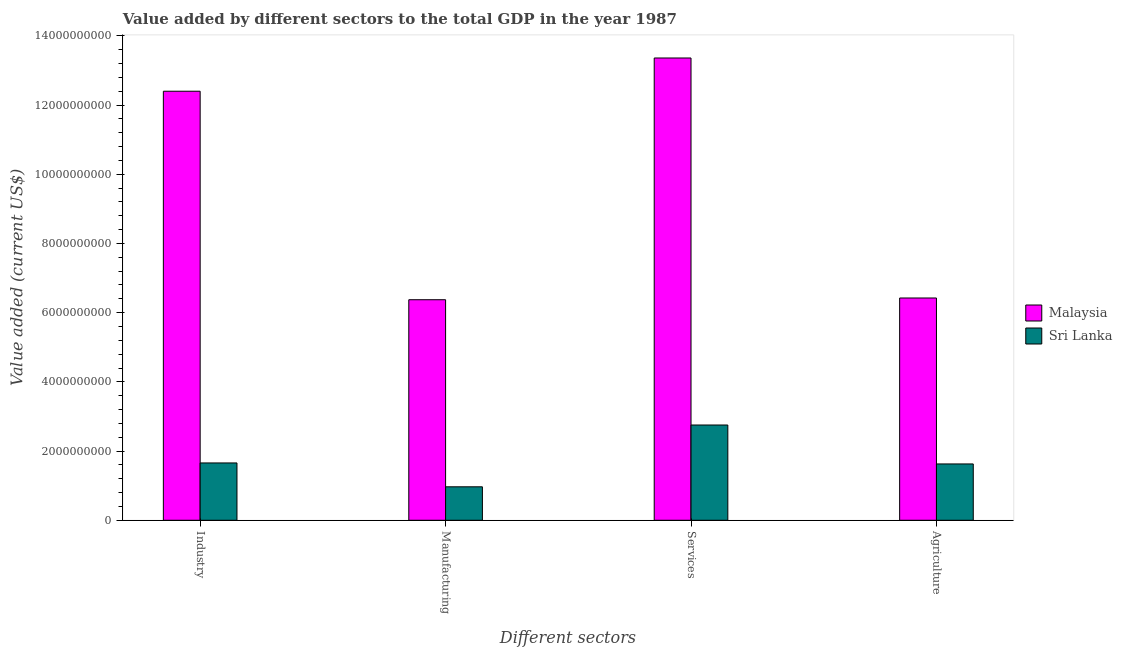Are the number of bars on each tick of the X-axis equal?
Keep it short and to the point. Yes. How many bars are there on the 3rd tick from the left?
Ensure brevity in your answer.  2. What is the label of the 4th group of bars from the left?
Give a very brief answer. Agriculture. What is the value added by services sector in Malaysia?
Make the answer very short. 1.34e+1. Across all countries, what is the maximum value added by manufacturing sector?
Make the answer very short. 6.37e+09. Across all countries, what is the minimum value added by manufacturing sector?
Offer a terse response. 9.67e+08. In which country was the value added by agricultural sector maximum?
Your answer should be very brief. Malaysia. In which country was the value added by manufacturing sector minimum?
Offer a terse response. Sri Lanka. What is the total value added by agricultural sector in the graph?
Your response must be concise. 8.05e+09. What is the difference between the value added by agricultural sector in Malaysia and that in Sri Lanka?
Ensure brevity in your answer.  4.80e+09. What is the difference between the value added by services sector in Malaysia and the value added by manufacturing sector in Sri Lanka?
Offer a very short reply. 1.24e+1. What is the average value added by agricultural sector per country?
Give a very brief answer. 4.03e+09. What is the difference between the value added by manufacturing sector and value added by industrial sector in Sri Lanka?
Offer a terse response. -6.89e+08. What is the ratio of the value added by manufacturing sector in Malaysia to that in Sri Lanka?
Your answer should be very brief. 6.59. Is the value added by services sector in Malaysia less than that in Sri Lanka?
Give a very brief answer. No. Is the difference between the value added by manufacturing sector in Sri Lanka and Malaysia greater than the difference between the value added by services sector in Sri Lanka and Malaysia?
Offer a terse response. Yes. What is the difference between the highest and the second highest value added by services sector?
Ensure brevity in your answer.  1.06e+1. What is the difference between the highest and the lowest value added by manufacturing sector?
Keep it short and to the point. 5.41e+09. In how many countries, is the value added by manufacturing sector greater than the average value added by manufacturing sector taken over all countries?
Offer a terse response. 1. Is it the case that in every country, the sum of the value added by agricultural sector and value added by manufacturing sector is greater than the sum of value added by services sector and value added by industrial sector?
Provide a succinct answer. No. What does the 2nd bar from the left in Manufacturing represents?
Provide a succinct answer. Sri Lanka. What does the 1st bar from the right in Services represents?
Offer a terse response. Sri Lanka. Is it the case that in every country, the sum of the value added by industrial sector and value added by manufacturing sector is greater than the value added by services sector?
Provide a succinct answer. No. How many bars are there?
Your response must be concise. 8. Does the graph contain any zero values?
Give a very brief answer. No. Does the graph contain grids?
Keep it short and to the point. No. Where does the legend appear in the graph?
Your response must be concise. Center right. What is the title of the graph?
Provide a short and direct response. Value added by different sectors to the total GDP in the year 1987. What is the label or title of the X-axis?
Offer a very short reply. Different sectors. What is the label or title of the Y-axis?
Your answer should be very brief. Value added (current US$). What is the Value added (current US$) of Malaysia in Industry?
Your response must be concise. 1.24e+1. What is the Value added (current US$) in Sri Lanka in Industry?
Keep it short and to the point. 1.66e+09. What is the Value added (current US$) of Malaysia in Manufacturing?
Your answer should be compact. 6.37e+09. What is the Value added (current US$) in Sri Lanka in Manufacturing?
Offer a terse response. 9.67e+08. What is the Value added (current US$) of Malaysia in Services?
Your answer should be very brief. 1.34e+1. What is the Value added (current US$) of Sri Lanka in Services?
Ensure brevity in your answer.  2.75e+09. What is the Value added (current US$) in Malaysia in Agriculture?
Ensure brevity in your answer.  6.42e+09. What is the Value added (current US$) in Sri Lanka in Agriculture?
Your response must be concise. 1.63e+09. Across all Different sectors, what is the maximum Value added (current US$) of Malaysia?
Your answer should be very brief. 1.34e+1. Across all Different sectors, what is the maximum Value added (current US$) of Sri Lanka?
Your answer should be compact. 2.75e+09. Across all Different sectors, what is the minimum Value added (current US$) of Malaysia?
Your response must be concise. 6.37e+09. Across all Different sectors, what is the minimum Value added (current US$) in Sri Lanka?
Your answer should be compact. 9.67e+08. What is the total Value added (current US$) of Malaysia in the graph?
Offer a very short reply. 3.86e+1. What is the total Value added (current US$) of Sri Lanka in the graph?
Keep it short and to the point. 7.00e+09. What is the difference between the Value added (current US$) of Malaysia in Industry and that in Manufacturing?
Keep it short and to the point. 6.03e+09. What is the difference between the Value added (current US$) of Sri Lanka in Industry and that in Manufacturing?
Your response must be concise. 6.89e+08. What is the difference between the Value added (current US$) in Malaysia in Industry and that in Services?
Offer a very short reply. -9.60e+08. What is the difference between the Value added (current US$) of Sri Lanka in Industry and that in Services?
Provide a short and direct response. -1.10e+09. What is the difference between the Value added (current US$) in Malaysia in Industry and that in Agriculture?
Your answer should be compact. 5.98e+09. What is the difference between the Value added (current US$) in Sri Lanka in Industry and that in Agriculture?
Provide a succinct answer. 2.85e+07. What is the difference between the Value added (current US$) in Malaysia in Manufacturing and that in Services?
Offer a very short reply. -6.99e+09. What is the difference between the Value added (current US$) of Sri Lanka in Manufacturing and that in Services?
Offer a very short reply. -1.79e+09. What is the difference between the Value added (current US$) in Malaysia in Manufacturing and that in Agriculture?
Give a very brief answer. -5.04e+07. What is the difference between the Value added (current US$) of Sri Lanka in Manufacturing and that in Agriculture?
Your response must be concise. -6.61e+08. What is the difference between the Value added (current US$) in Malaysia in Services and that in Agriculture?
Provide a short and direct response. 6.94e+09. What is the difference between the Value added (current US$) of Sri Lanka in Services and that in Agriculture?
Offer a very short reply. 1.13e+09. What is the difference between the Value added (current US$) in Malaysia in Industry and the Value added (current US$) in Sri Lanka in Manufacturing?
Provide a short and direct response. 1.14e+1. What is the difference between the Value added (current US$) in Malaysia in Industry and the Value added (current US$) in Sri Lanka in Services?
Ensure brevity in your answer.  9.65e+09. What is the difference between the Value added (current US$) of Malaysia in Industry and the Value added (current US$) of Sri Lanka in Agriculture?
Your response must be concise. 1.08e+1. What is the difference between the Value added (current US$) in Malaysia in Manufacturing and the Value added (current US$) in Sri Lanka in Services?
Provide a succinct answer. 3.62e+09. What is the difference between the Value added (current US$) in Malaysia in Manufacturing and the Value added (current US$) in Sri Lanka in Agriculture?
Your response must be concise. 4.75e+09. What is the difference between the Value added (current US$) in Malaysia in Services and the Value added (current US$) in Sri Lanka in Agriculture?
Give a very brief answer. 1.17e+1. What is the average Value added (current US$) of Malaysia per Different sectors?
Your response must be concise. 9.64e+09. What is the average Value added (current US$) in Sri Lanka per Different sectors?
Your answer should be very brief. 1.75e+09. What is the difference between the Value added (current US$) in Malaysia and Value added (current US$) in Sri Lanka in Industry?
Provide a short and direct response. 1.07e+1. What is the difference between the Value added (current US$) of Malaysia and Value added (current US$) of Sri Lanka in Manufacturing?
Give a very brief answer. 5.41e+09. What is the difference between the Value added (current US$) of Malaysia and Value added (current US$) of Sri Lanka in Services?
Your answer should be very brief. 1.06e+1. What is the difference between the Value added (current US$) of Malaysia and Value added (current US$) of Sri Lanka in Agriculture?
Provide a short and direct response. 4.80e+09. What is the ratio of the Value added (current US$) in Malaysia in Industry to that in Manufacturing?
Your answer should be compact. 1.95. What is the ratio of the Value added (current US$) of Sri Lanka in Industry to that in Manufacturing?
Provide a succinct answer. 1.71. What is the ratio of the Value added (current US$) of Malaysia in Industry to that in Services?
Your answer should be compact. 0.93. What is the ratio of the Value added (current US$) in Sri Lanka in Industry to that in Services?
Ensure brevity in your answer.  0.6. What is the ratio of the Value added (current US$) in Malaysia in Industry to that in Agriculture?
Keep it short and to the point. 1.93. What is the ratio of the Value added (current US$) in Sri Lanka in Industry to that in Agriculture?
Provide a succinct answer. 1.02. What is the ratio of the Value added (current US$) in Malaysia in Manufacturing to that in Services?
Your answer should be compact. 0.48. What is the ratio of the Value added (current US$) of Sri Lanka in Manufacturing to that in Services?
Your response must be concise. 0.35. What is the ratio of the Value added (current US$) of Malaysia in Manufacturing to that in Agriculture?
Make the answer very short. 0.99. What is the ratio of the Value added (current US$) of Sri Lanka in Manufacturing to that in Agriculture?
Make the answer very short. 0.59. What is the ratio of the Value added (current US$) of Malaysia in Services to that in Agriculture?
Make the answer very short. 2.08. What is the ratio of the Value added (current US$) in Sri Lanka in Services to that in Agriculture?
Your response must be concise. 1.69. What is the difference between the highest and the second highest Value added (current US$) of Malaysia?
Offer a very short reply. 9.60e+08. What is the difference between the highest and the second highest Value added (current US$) of Sri Lanka?
Keep it short and to the point. 1.10e+09. What is the difference between the highest and the lowest Value added (current US$) in Malaysia?
Make the answer very short. 6.99e+09. What is the difference between the highest and the lowest Value added (current US$) of Sri Lanka?
Keep it short and to the point. 1.79e+09. 